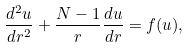<formula> <loc_0><loc_0><loc_500><loc_500>\frac { d ^ { 2 } u } { d r ^ { 2 } } + \frac { N - 1 } { r } \frac { d u } { d r } = f ( u ) ,</formula> 